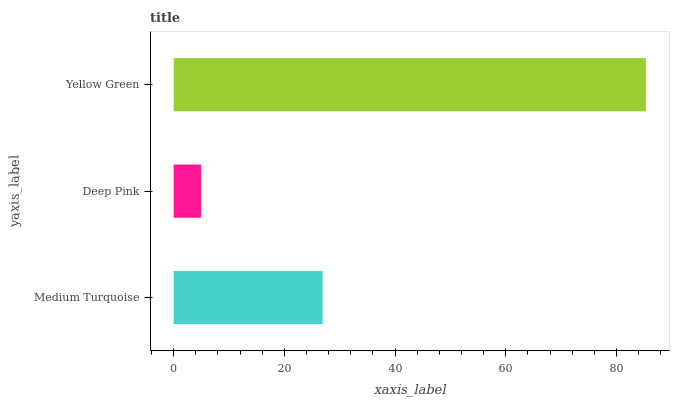Is Deep Pink the minimum?
Answer yes or no. Yes. Is Yellow Green the maximum?
Answer yes or no. Yes. Is Yellow Green the minimum?
Answer yes or no. No. Is Deep Pink the maximum?
Answer yes or no. No. Is Yellow Green greater than Deep Pink?
Answer yes or no. Yes. Is Deep Pink less than Yellow Green?
Answer yes or no. Yes. Is Deep Pink greater than Yellow Green?
Answer yes or no. No. Is Yellow Green less than Deep Pink?
Answer yes or no. No. Is Medium Turquoise the high median?
Answer yes or no. Yes. Is Medium Turquoise the low median?
Answer yes or no. Yes. Is Yellow Green the high median?
Answer yes or no. No. Is Yellow Green the low median?
Answer yes or no. No. 